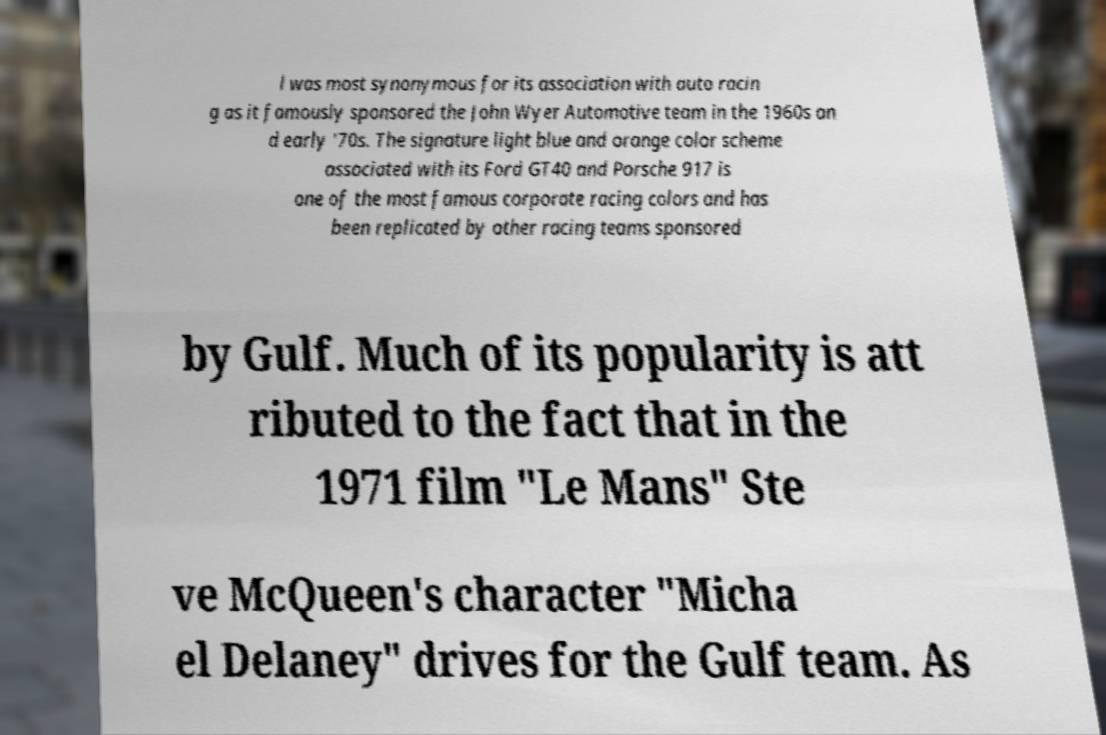Can you accurately transcribe the text from the provided image for me? l was most synonymous for its association with auto racin g as it famously sponsored the John Wyer Automotive team in the 1960s an d early '70s. The signature light blue and orange color scheme associated with its Ford GT40 and Porsche 917 is one of the most famous corporate racing colors and has been replicated by other racing teams sponsored by Gulf. Much of its popularity is att ributed to the fact that in the 1971 film "Le Mans" Ste ve McQueen's character "Micha el Delaney" drives for the Gulf team. As 